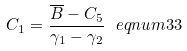<formula> <loc_0><loc_0><loc_500><loc_500>C _ { 1 } = \frac { \overline { B } - C _ { 5 } } { \gamma _ { 1 } - \gamma _ { 2 } } \ e q n u m { 3 3 }</formula> 